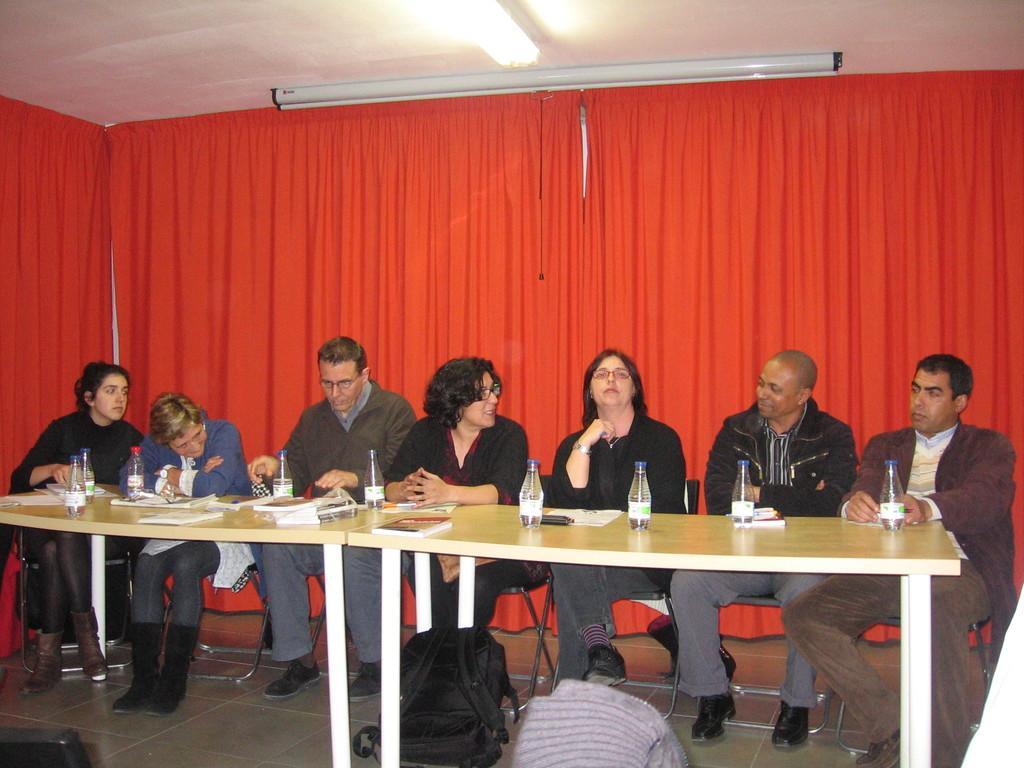In one or two sentences, can you explain what this image depicts? Here we can see a group of people sitting on chairs and there is a table in front of them and each of them have bottles in front of them behind them there is a red curtain present 